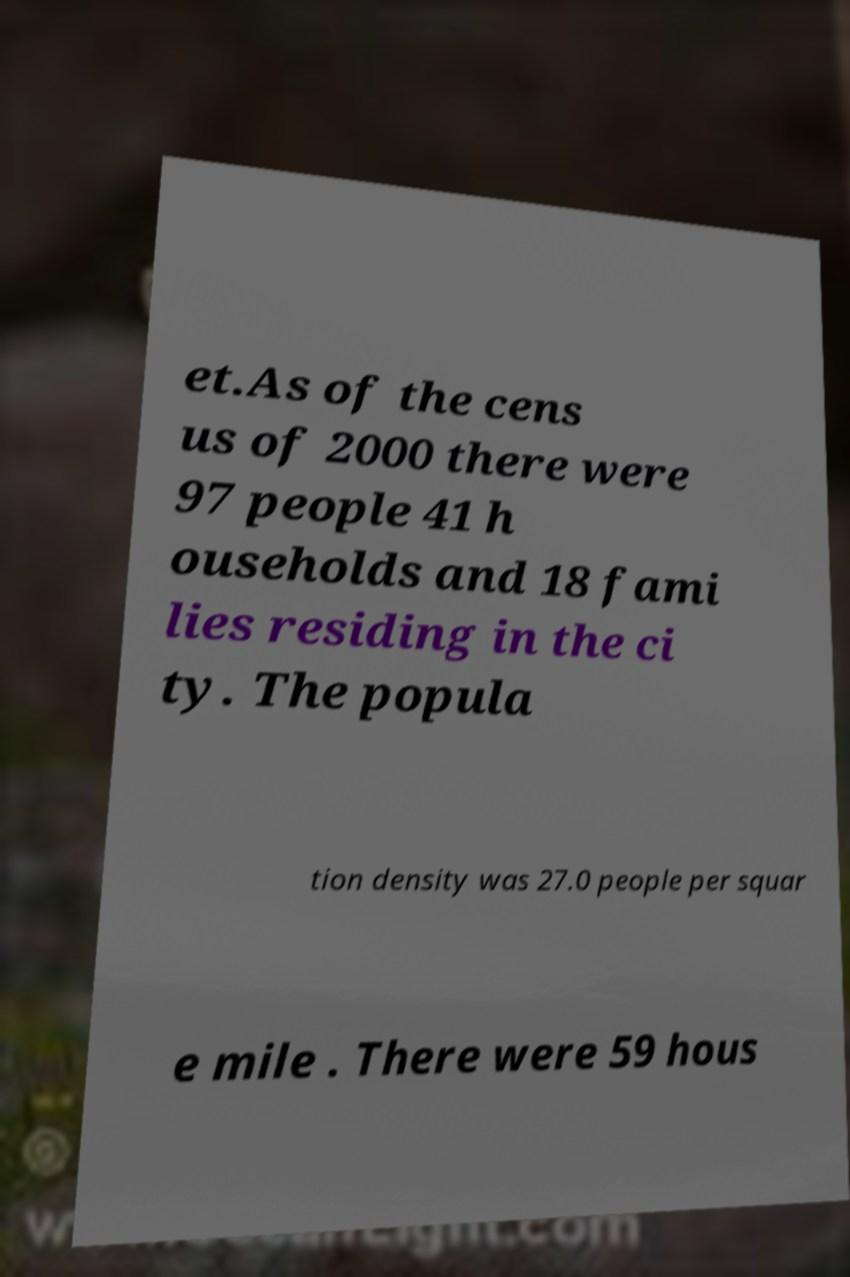Can you accurately transcribe the text from the provided image for me? et.As of the cens us of 2000 there were 97 people 41 h ouseholds and 18 fami lies residing in the ci ty. The popula tion density was 27.0 people per squar e mile . There were 59 hous 